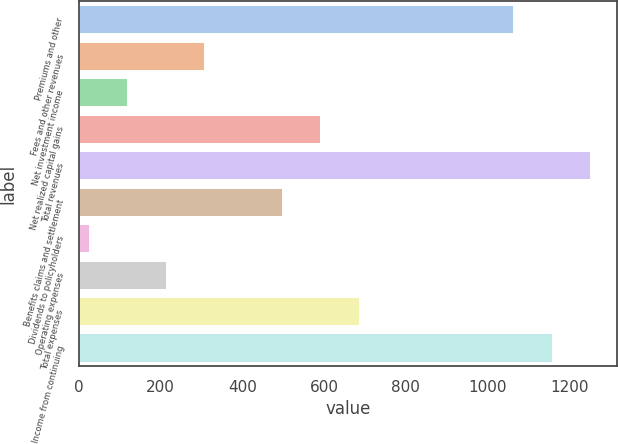Convert chart. <chart><loc_0><loc_0><loc_500><loc_500><bar_chart><fcel>Premiums and other<fcel>Fees and other revenues<fcel>Net investment income<fcel>Net realized capital gains<fcel>Total revenues<fcel>Benefits claims and settlement<fcel>Dividends to policyholders<fcel>Operating expenses<fcel>Total expenses<fcel>Income from continuing<nl><fcel>1065.01<fcel>309.73<fcel>120.91<fcel>592.96<fcel>1253.83<fcel>498.55<fcel>26.5<fcel>215.32<fcel>687.37<fcel>1159.42<nl></chart> 